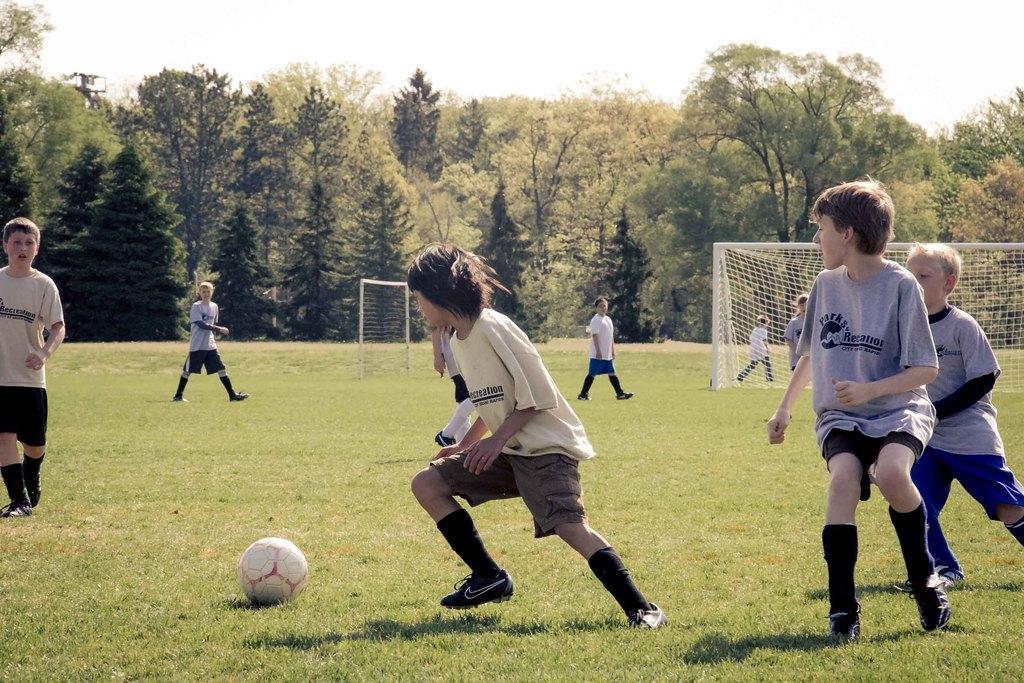Can you describe this image briefly? In this image I see the ground and I see number of children and I see a ball in front. In the middle of this picture I see number of trees and I see 2 goalposts. In the background I see the sky. 